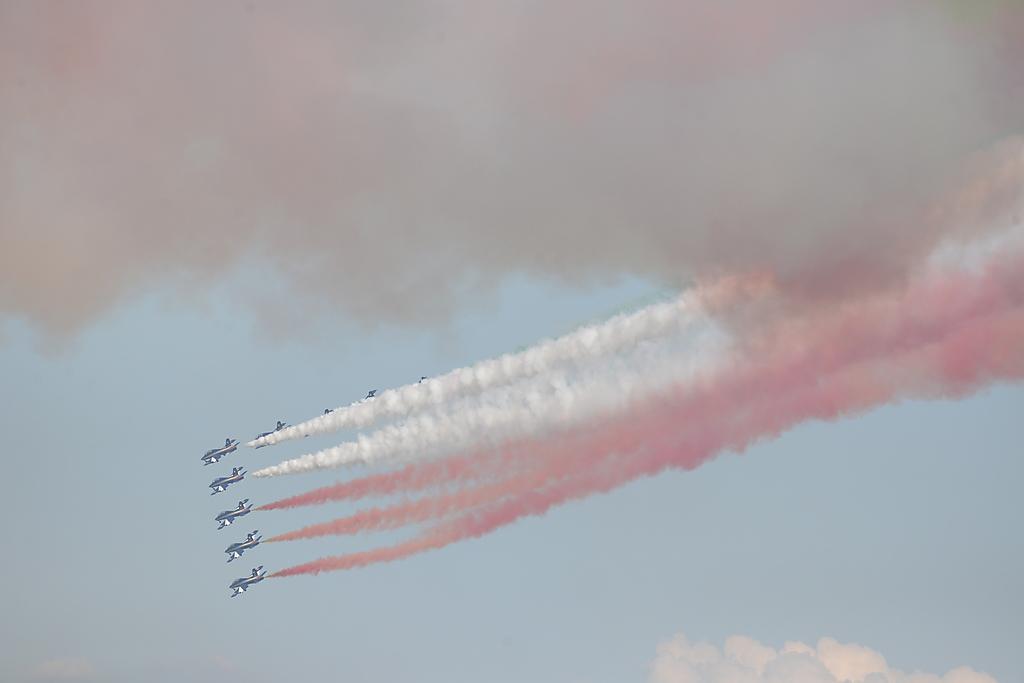Please provide a concise description of this image. In this image we can see some jets with smoke in the sky. We can also see that the sky looks cloudy. 